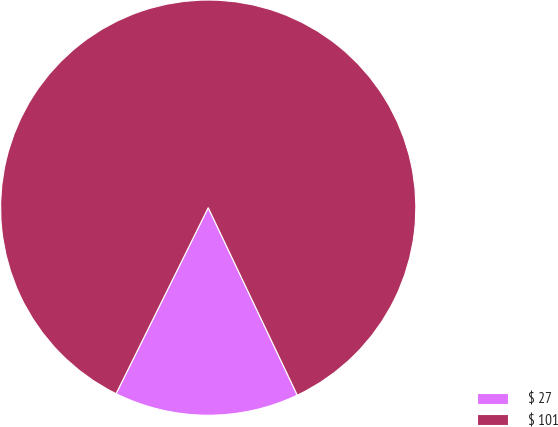<chart> <loc_0><loc_0><loc_500><loc_500><pie_chart><fcel>$ 27<fcel>$ 101<nl><fcel>14.38%<fcel>85.62%<nl></chart> 